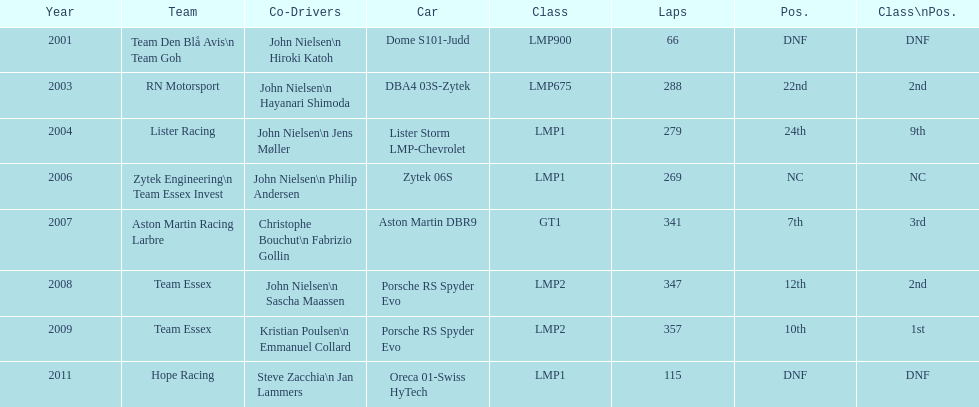In 2008 and what other year was casper elgaard on team essex for the 24 hours of le mans? 2009. 